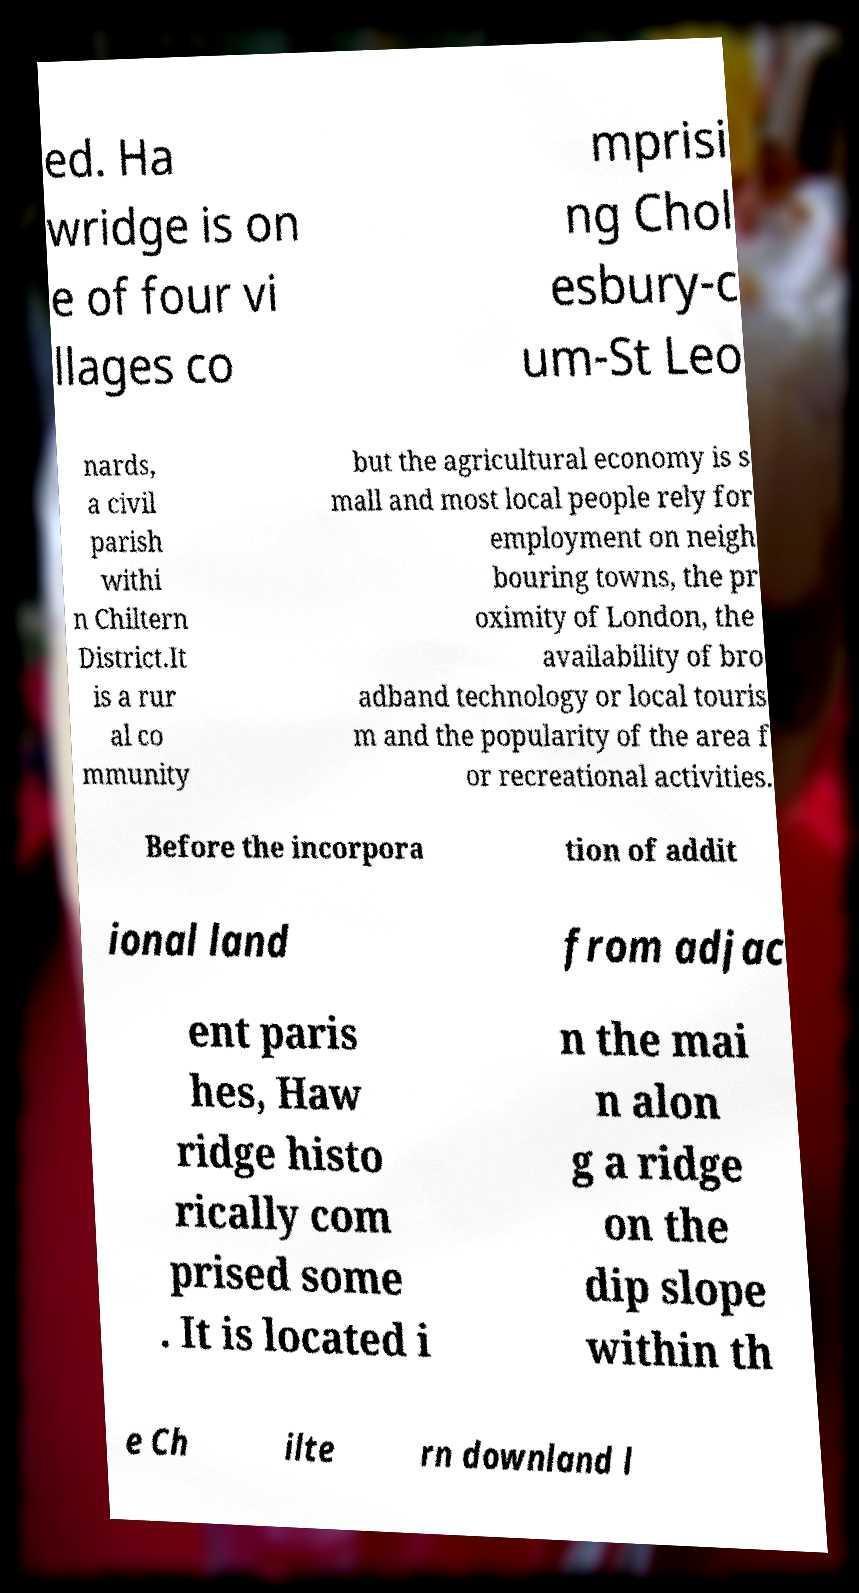Please read and relay the text visible in this image. What does it say? ed. Ha wridge is on e of four vi llages co mprisi ng Chol esbury-c um-St Leo nards, a civil parish withi n Chiltern District.It is a rur al co mmunity but the agricultural economy is s mall and most local people rely for employment on neigh bouring towns, the pr oximity of London, the availability of bro adband technology or local touris m and the popularity of the area f or recreational activities. Before the incorpora tion of addit ional land from adjac ent paris hes, Haw ridge histo rically com prised some . It is located i n the mai n alon g a ridge on the dip slope within th e Ch ilte rn downland l 